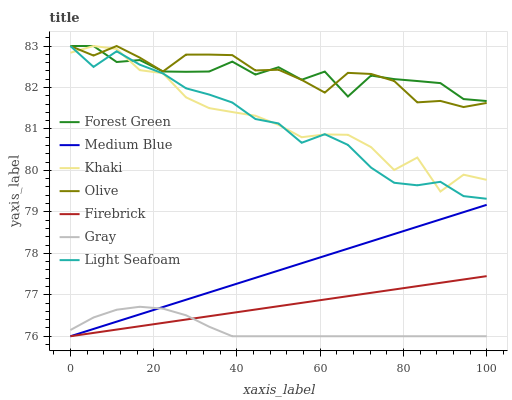Does Gray have the minimum area under the curve?
Answer yes or no. Yes. Does Olive have the maximum area under the curve?
Answer yes or no. Yes. Does Khaki have the minimum area under the curve?
Answer yes or no. No. Does Khaki have the maximum area under the curve?
Answer yes or no. No. Is Firebrick the smoothest?
Answer yes or no. Yes. Is Khaki the roughest?
Answer yes or no. Yes. Is Khaki the smoothest?
Answer yes or no. No. Is Firebrick the roughest?
Answer yes or no. No. Does Gray have the lowest value?
Answer yes or no. Yes. Does Khaki have the lowest value?
Answer yes or no. No. Does Light Seafoam have the highest value?
Answer yes or no. Yes. Does Firebrick have the highest value?
Answer yes or no. No. Is Firebrick less than Forest Green?
Answer yes or no. Yes. Is Forest Green greater than Medium Blue?
Answer yes or no. Yes. Does Khaki intersect Olive?
Answer yes or no. Yes. Is Khaki less than Olive?
Answer yes or no. No. Is Khaki greater than Olive?
Answer yes or no. No. Does Firebrick intersect Forest Green?
Answer yes or no. No. 